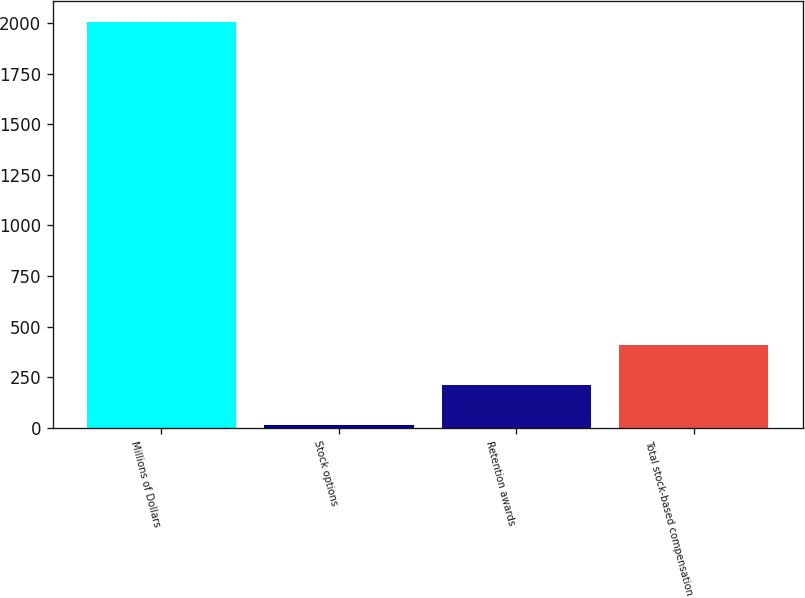<chart> <loc_0><loc_0><loc_500><loc_500><bar_chart><fcel>Millions of Dollars<fcel>Stock options<fcel>Retention awards<fcel>Total stock-based compensation<nl><fcel>2006<fcel>14<fcel>213.2<fcel>412.4<nl></chart> 